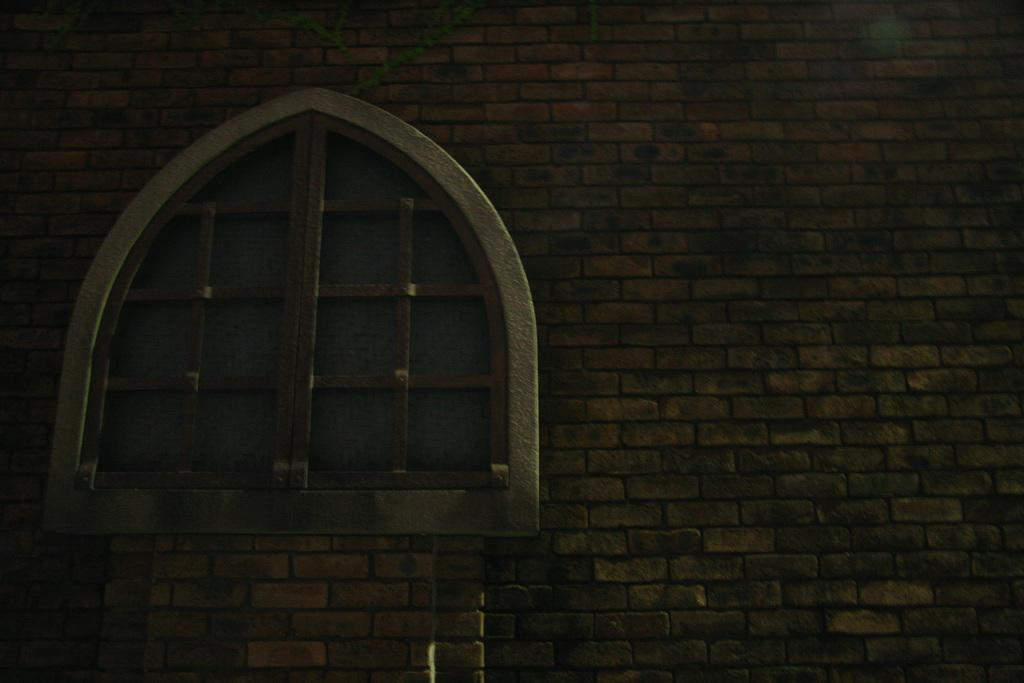What is a prominent feature in the image? There is a window in the image. Can you describe the location of the window? The window is part of a wall. What type of vegetation can be seen at the top of the image? There are creepers visible at the top of the image. What type of juice is being served on the day depicted in the image? There is no juice or indication of a specific day in the image; it only features a window, a wall, and creepers. 